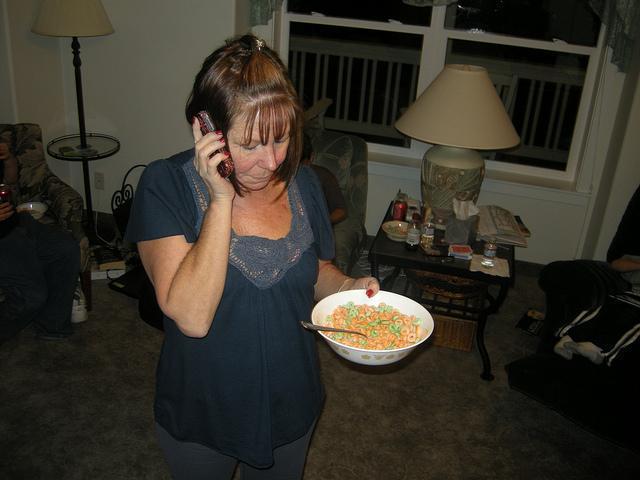How many people are visible?
Give a very brief answer. 3. How many chairs can be seen?
Give a very brief answer. 2. How many couches are there?
Give a very brief answer. 2. 